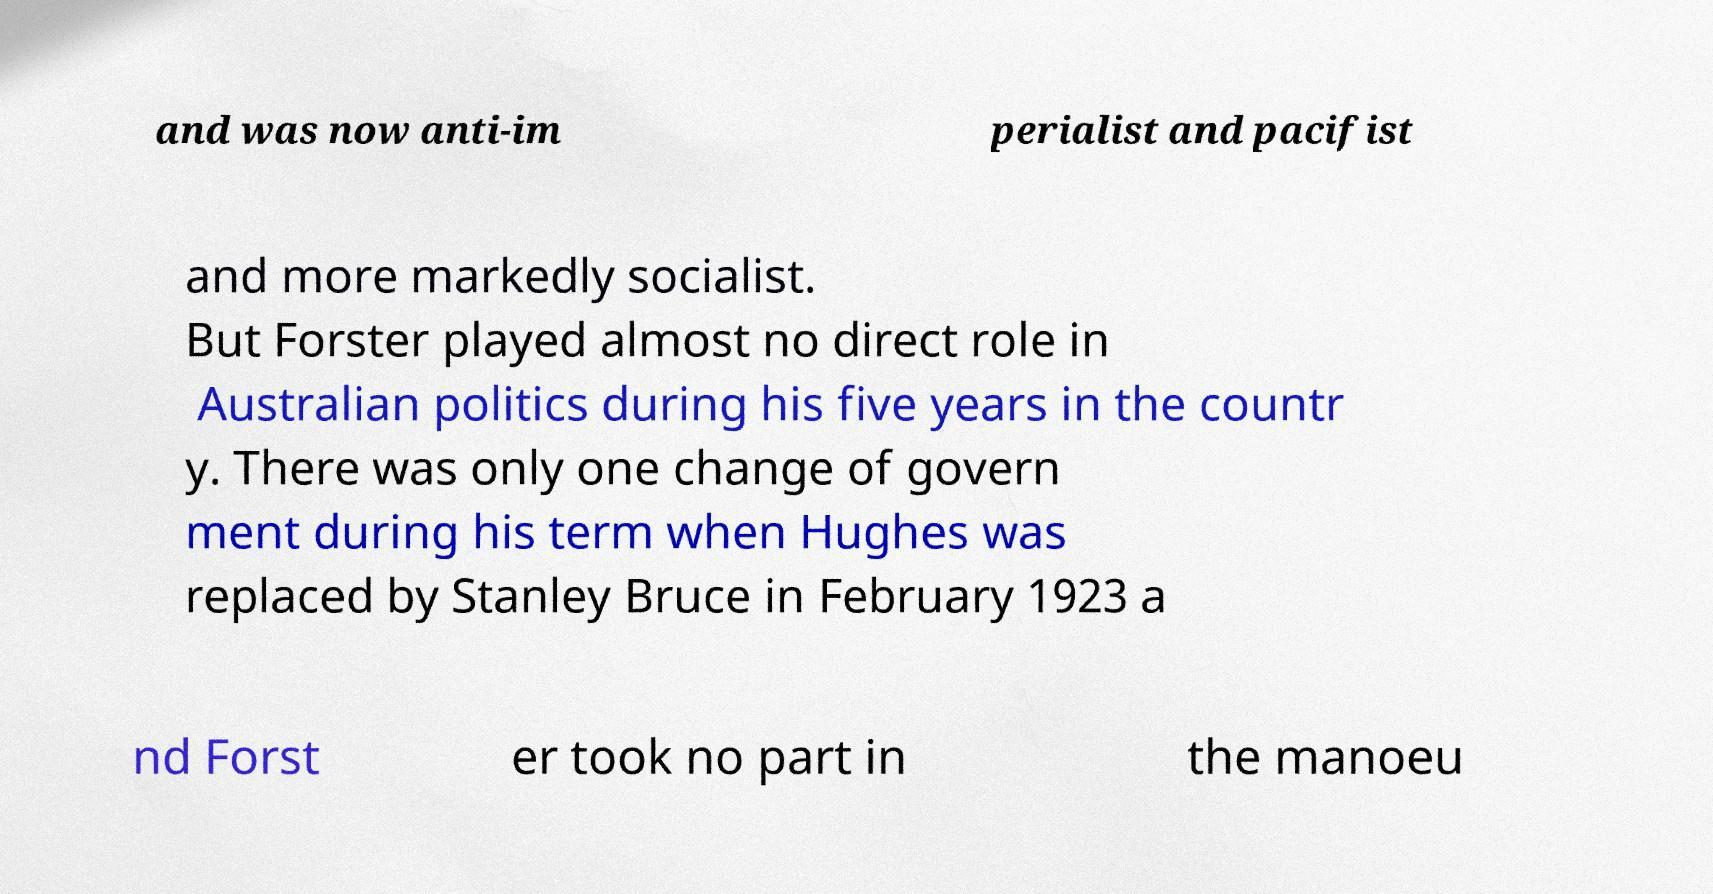Could you extract and type out the text from this image? and was now anti-im perialist and pacifist and more markedly socialist. But Forster played almost no direct role in Australian politics during his five years in the countr y. There was only one change of govern ment during his term when Hughes was replaced by Stanley Bruce in February 1923 a nd Forst er took no part in the manoeu 